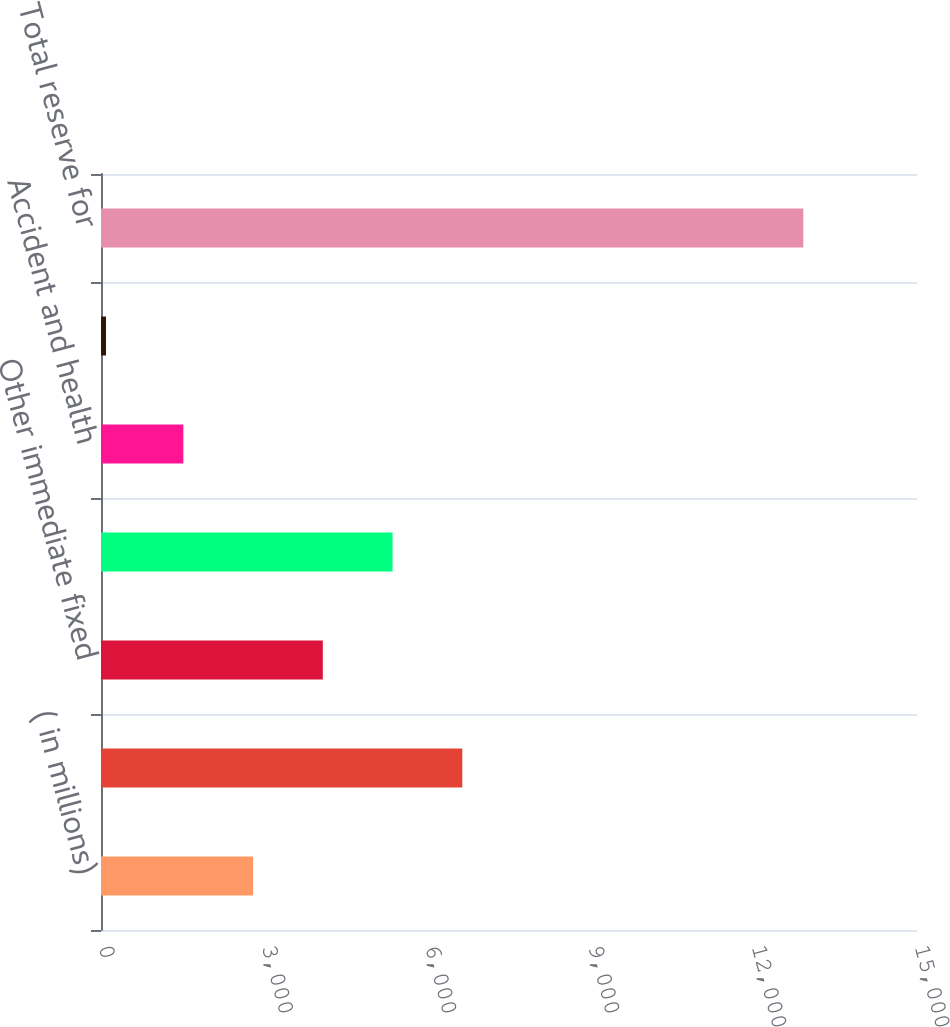Convert chart. <chart><loc_0><loc_0><loc_500><loc_500><bar_chart><fcel>( in millions)<fcel>Structured settlement<fcel>Other immediate fixed<fcel>Traditional life insurance<fcel>Accident and health<fcel>Other<fcel>Total reserve for<nl><fcel>2795.8<fcel>6641.2<fcel>4077.6<fcel>5359.4<fcel>1514<fcel>92<fcel>12910<nl></chart> 